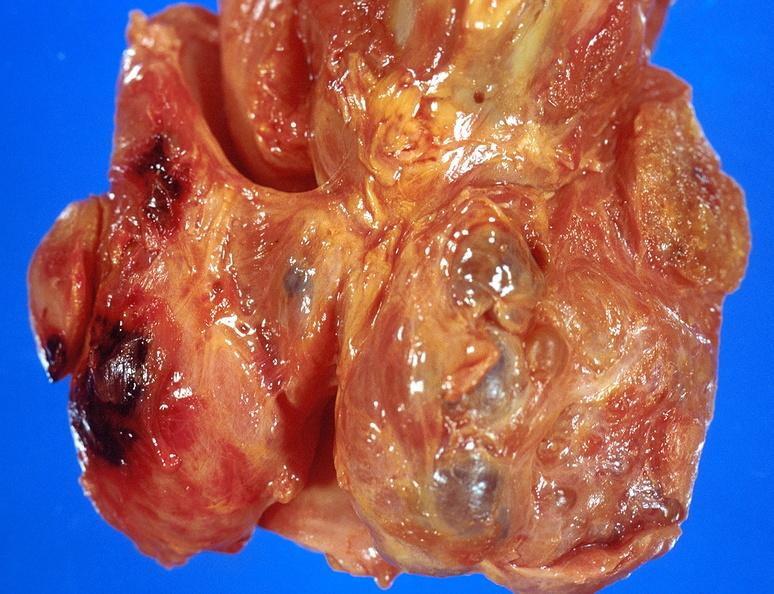does lymphangiomatosis generalized show thyroid, goiter?
Answer the question using a single word or phrase. No 